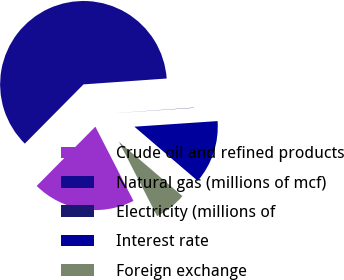Convert chart to OTSL. <chart><loc_0><loc_0><loc_500><loc_500><pie_chart><fcel>Crude oil and refined products<fcel>Natural gas (millions of mcf)<fcel>Electricity (millions of<fcel>Interest rate<fcel>Foreign exchange<nl><fcel>19.97%<fcel>61.45%<fcel>0.05%<fcel>12.33%<fcel>6.19%<nl></chart> 